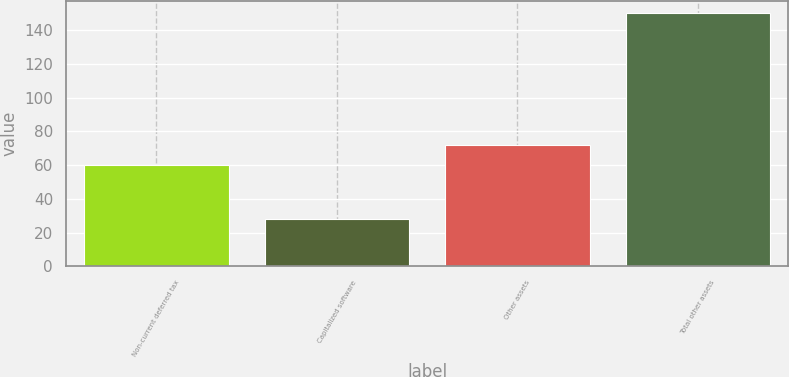Convert chart to OTSL. <chart><loc_0><loc_0><loc_500><loc_500><bar_chart><fcel>Non-current deferred tax<fcel>Capitalized software<fcel>Other assets<fcel>Total other assets<nl><fcel>60<fcel>28<fcel>72.2<fcel>150<nl></chart> 